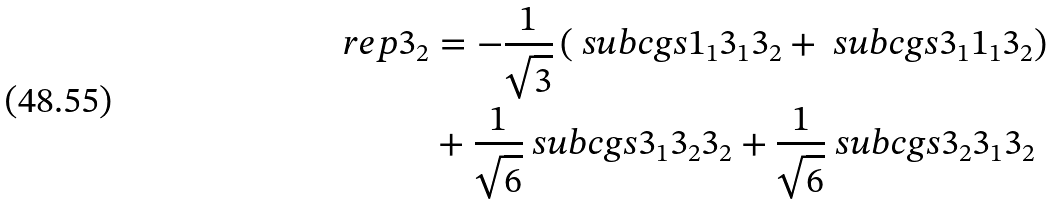Convert formula to latex. <formula><loc_0><loc_0><loc_500><loc_500>\ r e p { 3 } _ { 2 } & = - \frac { 1 } { \sqrt { 3 } } \left ( \ s u b c g s { 1 _ { 1 } } { 3 _ { 1 } } { 3 _ { 2 } } + \ s u b c g s { 3 _ { 1 } } { 1 _ { 1 } } { 3 _ { 2 } } \right ) \\ & + \frac { 1 } { \sqrt { 6 } } \ s u b c g s { 3 _ { 1 } } { 3 _ { 2 } } { 3 _ { 2 } } + \frac { 1 } { \sqrt { 6 } } \ s u b c g s { 3 _ { 2 } } { 3 _ { 1 } } { 3 _ { 2 } }</formula> 